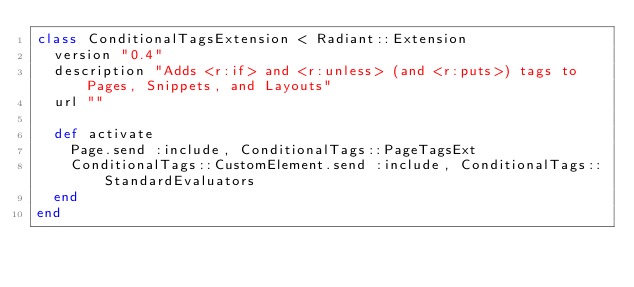Convert code to text. <code><loc_0><loc_0><loc_500><loc_500><_Ruby_>class ConditionalTagsExtension < Radiant::Extension
  version "0.4"
  description "Adds <r:if> and <r:unless> (and <r:puts>) tags to Pages, Snippets, and Layouts"
  url ""

  def activate
    Page.send :include, ConditionalTags::PageTagsExt
    ConditionalTags::CustomElement.send :include, ConditionalTags::StandardEvaluators
  end
end</code> 